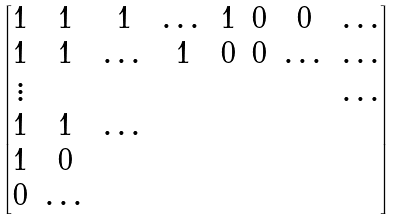<formula> <loc_0><loc_0><loc_500><loc_500>\begin{bmatrix} 1 & 1 & 1 & \dots & 1 & 0 & 0 & \dots \\ 1 & 1 & \dots & 1 & 0 & 0 & \dots & \dots \\ \vdots & & & & & & & \dots \\ 1 & 1 & \dots & & & & & \\ 1 & 0 & & & & & & \\ 0 & \dots & & & & & & \\ \end{bmatrix}</formula> 